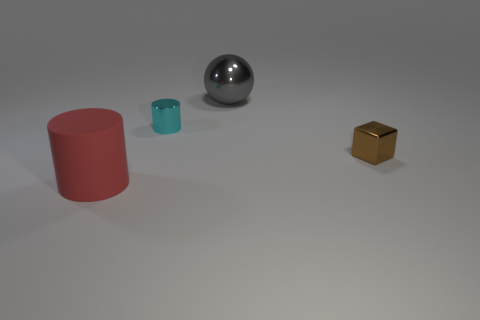There is another small thing that is the same shape as the red object; what is it made of?
Ensure brevity in your answer.  Metal. What is the material of the large red thing?
Offer a terse response. Rubber. What shape is the gray shiny object that is the same size as the red thing?
Provide a succinct answer. Sphere. Are there any large cylinders that have the same color as the tiny cylinder?
Give a very brief answer. No. There is a small metallic thing that is behind the thing right of the large gray thing; what is its color?
Your response must be concise. Cyan. Is there a big red object left of the big thing that is behind the cylinder that is behind the matte cylinder?
Give a very brief answer. Yes. The small cube that is made of the same material as the big ball is what color?
Give a very brief answer. Brown. What number of blocks are made of the same material as the large red thing?
Provide a short and direct response. 0. Is the brown thing made of the same material as the cylinder that is in front of the tiny cyan metallic cylinder?
Ensure brevity in your answer.  No. What number of objects are things left of the shiny cylinder or red balls?
Offer a very short reply. 1. 